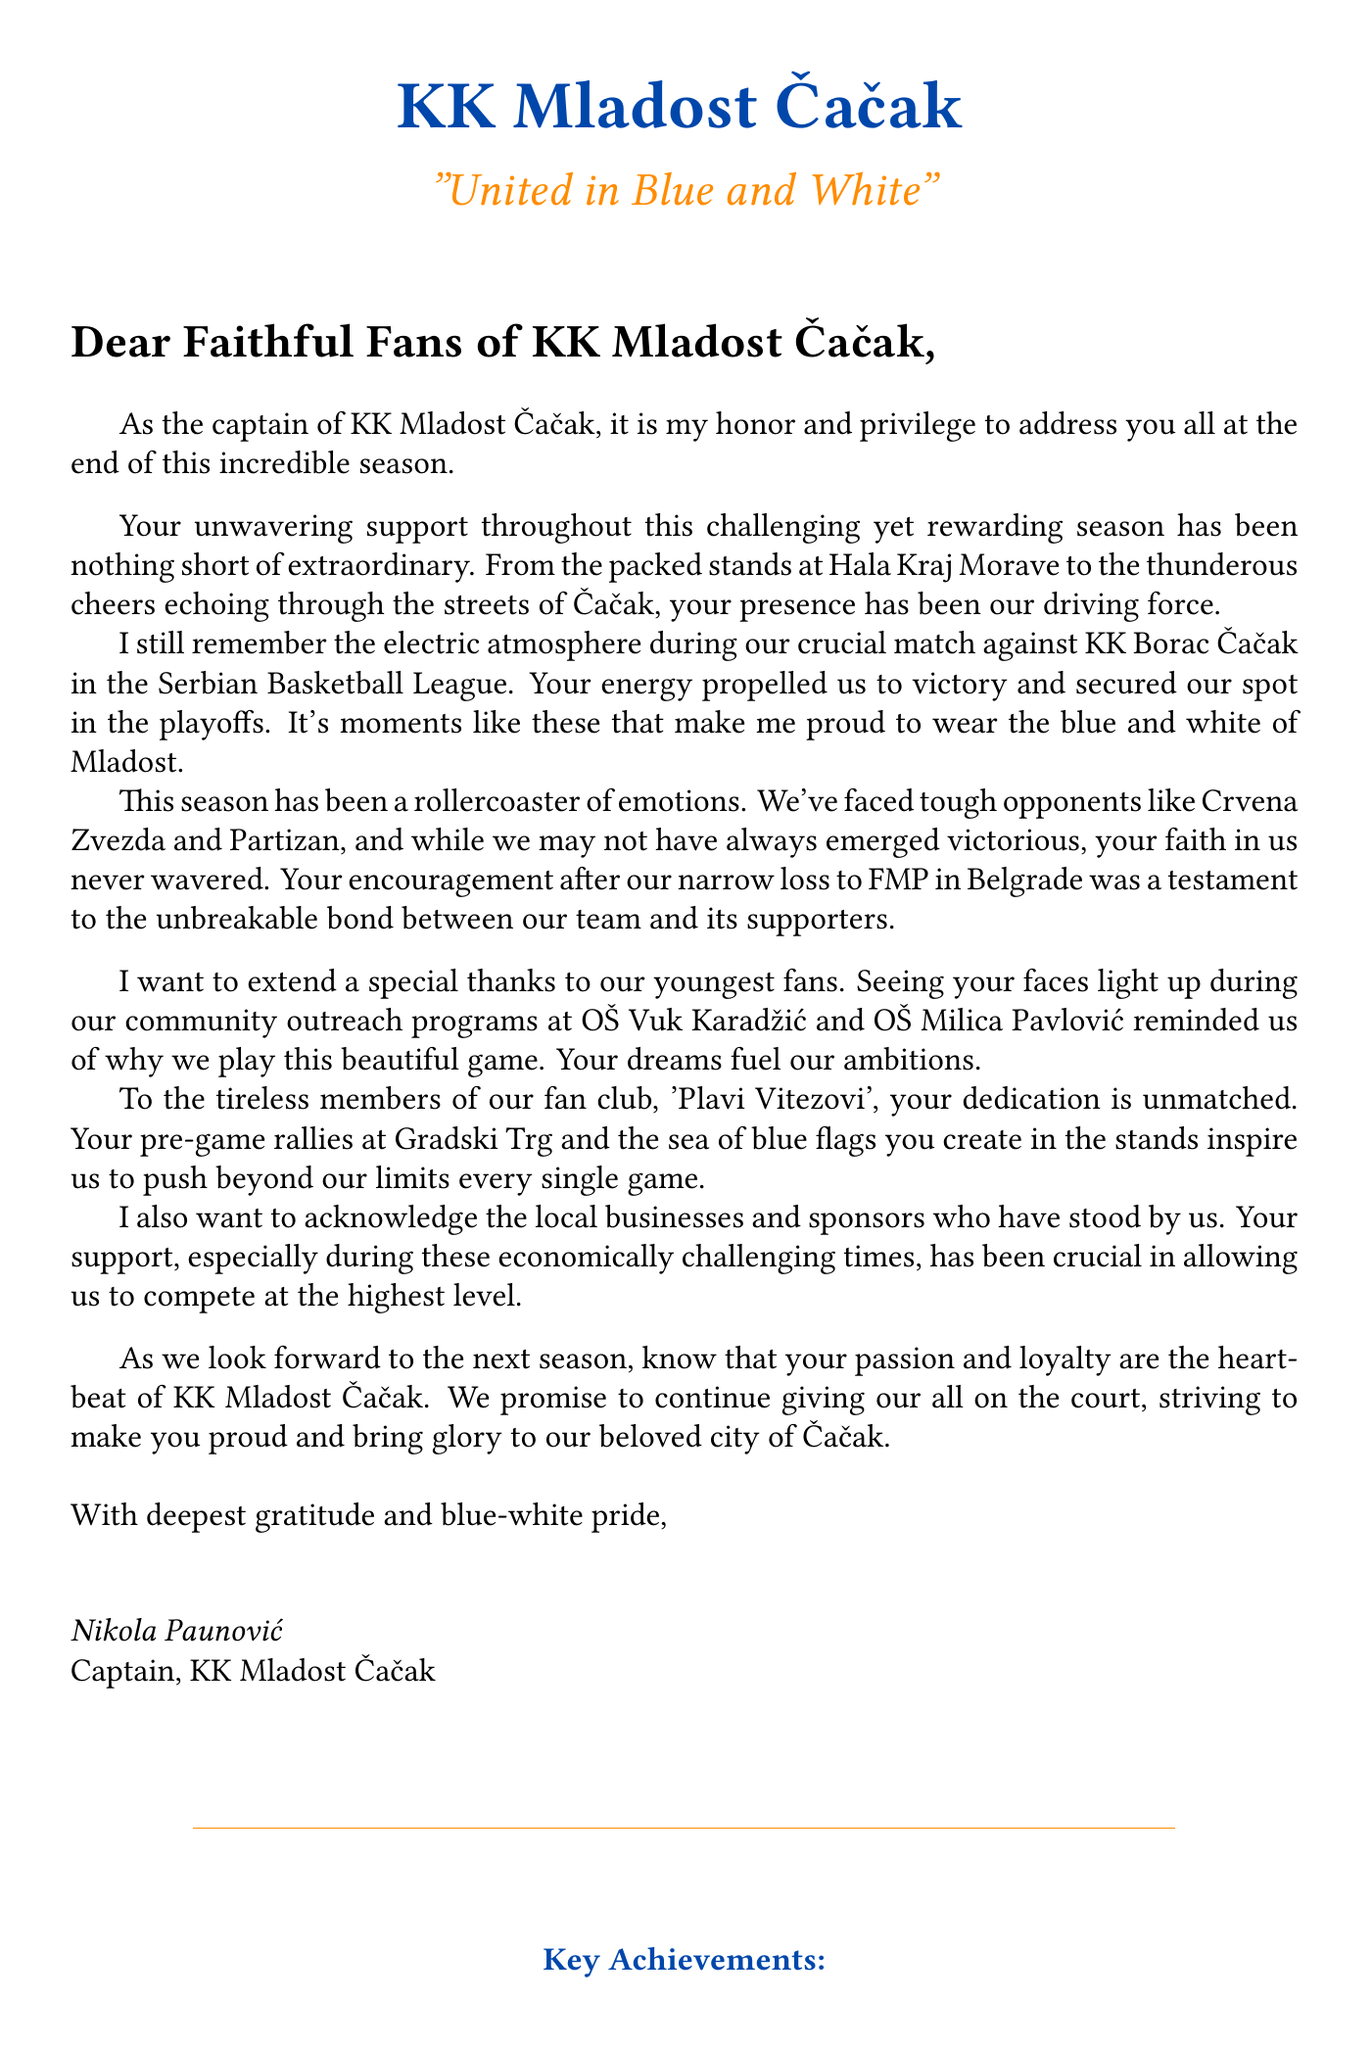What is the name of the team captain? The letter is signed by Nikola Paunović, who is the captain of KK Mladost Čačak.
Answer: Nikola Paunović Which phrase expresses the team's motto? The slogan in the letter is "United in Blue and White," which represents the team's identity and camaraderie.
Answer: United in Blue and White What is one memorable match mentioned in the letter? The letter recalls a crucial match against KK Borac Čačak, highlighting its significance in the season.
Answer: KK Borac Čačak What does the team aim for in the next season? The letter mentions aspirations to strive for a higher league position in the coming season among other goals.
Answer: Higher league position Who is thanked for their pre-game rallies? The letter appreciates the tireless members of the fan club named "Plavi Vitezovi" for their dedicated support.
Answer: Plavi Vitezovi What local schools are mentioned in the community outreach programs? The letter references OŠ Vuk Karadžić and OŠ Milica Pavlović as part of their community engagement initiatives.
Answer: OŠ Vuk Karadžić and OŠ Milica Pavlović Which tough opponents did the team face? The letter lists tough opponents including Crvena Zvezda and Partizan, indicating high competition during the season.
Answer: Crvena Zvezda and Partizan What is the location of the team's home court? The letter mentions Hala Kraj Morave as the location of their home games, showcasing their support base.
Answer: Hala Kraj Morave 